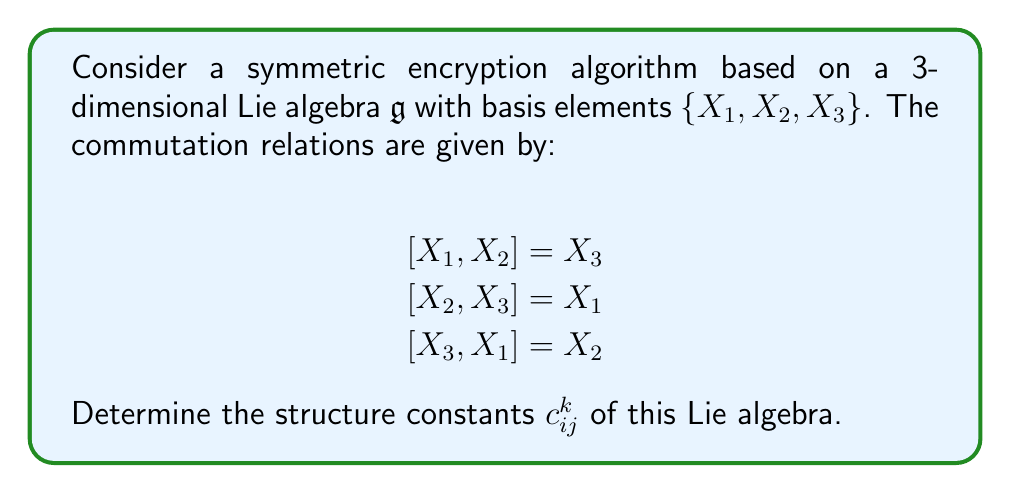Could you help me with this problem? To determine the structure constants of a Lie algebra, we need to express the commutation relations in terms of the structure constants $c_{ij}^k$. The general form of the commutation relations is:

$$[X_i, X_j] = \sum_{k=1}^3 c_{ij}^k X_k$$

where $c_{ij}^k$ are the structure constants.

Let's analyze each commutation relation:

1. $[X_1, X_2] = X_3$:
   This implies $c_{12}^3 = 1$, and $c_{12}^1 = c_{12}^2 = 0$.

2. $[X_2, X_3] = X_1$:
   This implies $c_{23}^1 = 1$, and $c_{23}^2 = c_{23}^3 = 0$.

3. $[X_3, X_1] = X_2$:
   This implies $c_{31}^2 = 1$, and $c_{31}^1 = c_{31}^3 = 0$.

Additionally, we can deduce:

4. $[X_2, X_1] = -[X_1, X_2] = -X_3$:
   This implies $c_{21}^3 = -1$, and $c_{21}^1 = c_{21}^2 = 0$.

5. $[X_3, X_2] = -[X_2, X_3] = -X_1$:
   This implies $c_{32}^1 = -1$, and $c_{32}^2 = c_{32}^3 = 0$.

6. $[X_1, X_3] = -[X_3, X_1] = -X_2$:
   This implies $c_{13}^2 = -1$, and $c_{13}^1 = c_{13}^3 = 0$.

All other structure constants are zero due to the antisymmetry property of the Lie bracket: $[X_i, X_i] = 0$ for all $i$.

Therefore, we have determined all non-zero structure constants of the Lie algebra.
Answer: The non-zero structure constants of the Lie algebra are:

$$c_{12}^3 = c_{23}^1 = c_{31}^2 = 1$$
$$c_{21}^3 = c_{32}^1 = c_{13}^2 = -1$$

All other structure constants are zero. 